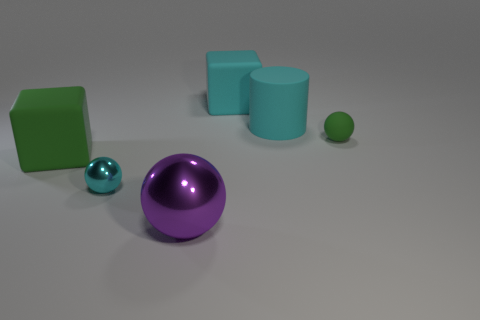How many large things are the same color as the rubber ball?
Provide a short and direct response. 1. Does the big rubber cylinder have the same color as the small object left of the big cyan matte cube?
Offer a terse response. Yes. What shape is the matte object that is both on the left side of the cylinder and behind the tiny green sphere?
Make the answer very short. Cube. There is a block that is right of the big cube to the left of the cube right of the large purple shiny ball; what is its material?
Your answer should be very brief. Rubber. Is the number of large cyan things that are behind the rubber cylinder greater than the number of big purple metal objects that are in front of the purple sphere?
Ensure brevity in your answer.  Yes. How many big blocks are made of the same material as the green sphere?
Your answer should be very brief. 2. There is a large thing in front of the big green thing; does it have the same shape as the cyan object behind the large cyan cylinder?
Your response must be concise. No. There is a big block that is behind the large cylinder; what is its color?
Provide a succinct answer. Cyan. Is there a green rubber thing that has the same shape as the big shiny object?
Your response must be concise. Yes. What is the purple sphere made of?
Your response must be concise. Metal. 